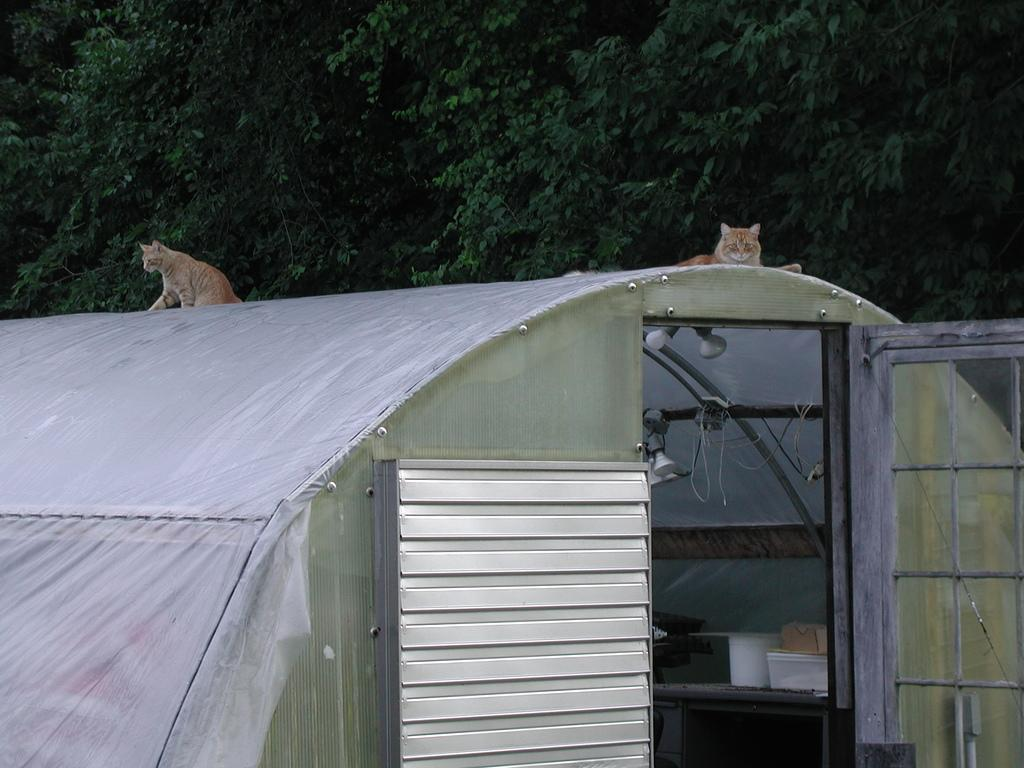How many cats are in the image? There are two cats in the image. Where are the cats sitting? The cats are sitting on a shed. What can be found inside the shed? There are electric lights and shelves inside the shed. What can be seen in the background of the image? There is a tree visible in the background of the image. What type of lettuce is being used as a car seat cover in the image? There is no car or lettuce present in the image; it features two cats sitting on a shed. 